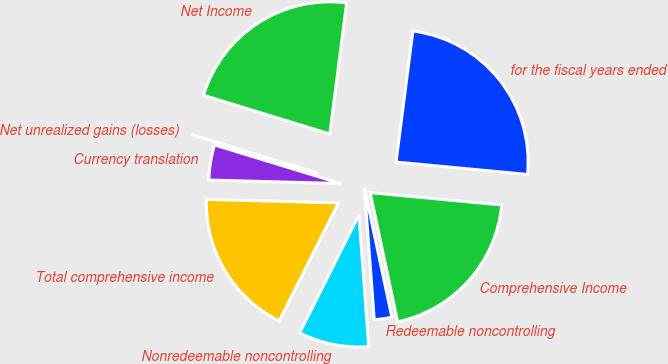Convert chart. <chart><loc_0><loc_0><loc_500><loc_500><pie_chart><fcel>for the fiscal years ended<fcel>Net Income<fcel>Net unrealized gains (losses)<fcel>Currency translation<fcel>Total comprehensive income<fcel>Nonredeemable noncontrolling<fcel>Redeemable noncontrolling<fcel>Comprehensive Income<nl><fcel>24.46%<fcel>22.31%<fcel>0.0%<fcel>4.3%<fcel>18.02%<fcel>8.59%<fcel>2.15%<fcel>20.17%<nl></chart> 